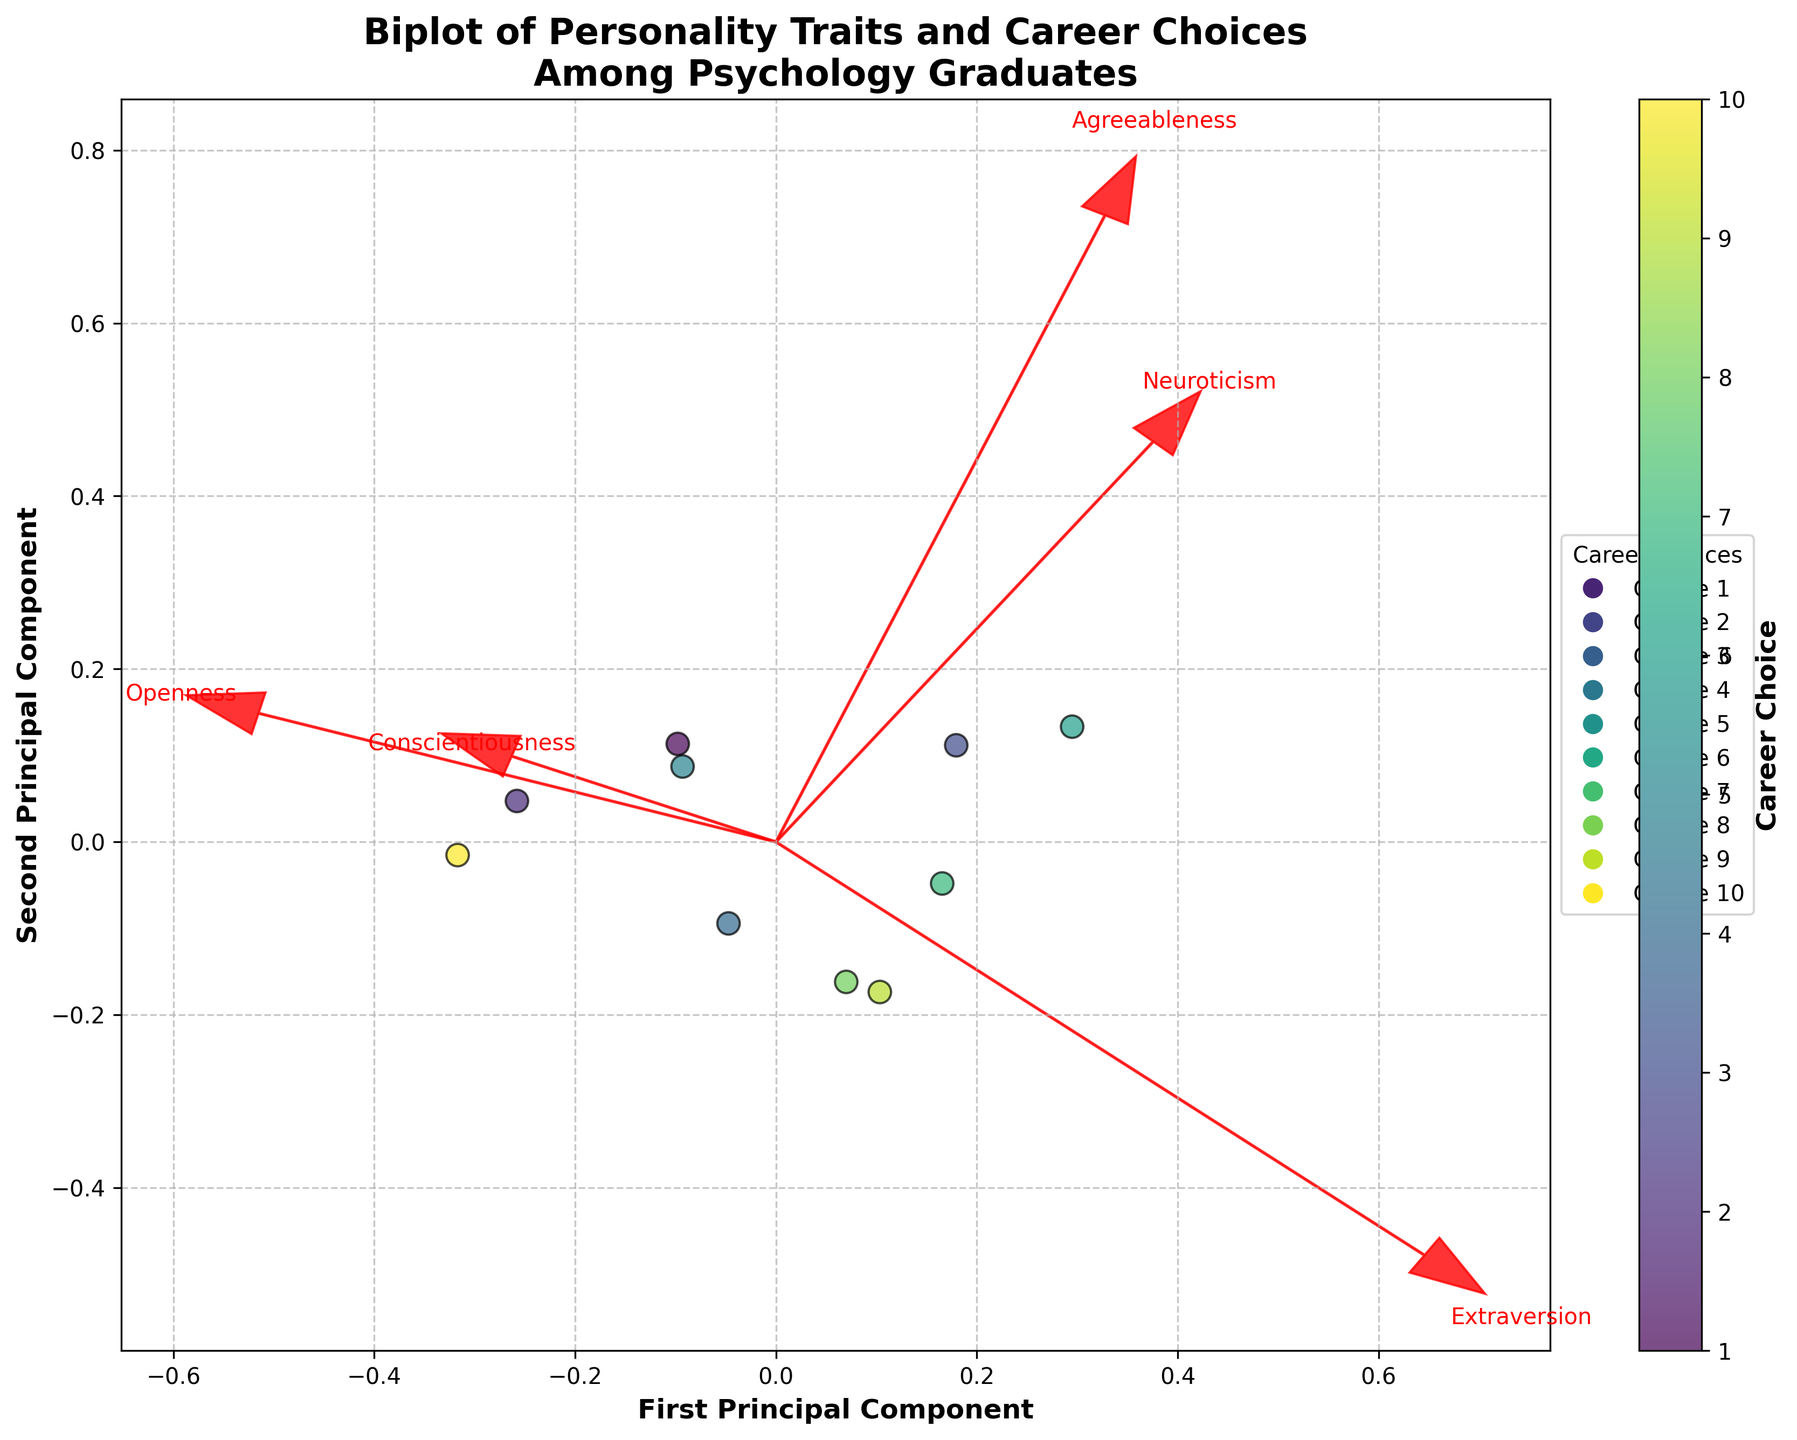what's the title of the figure? The title can be found at the top of the figure where the title text is usually placed. It reads "Biplot of Personality Traits and Career Choices\nAmong Psychology Graduates".
Answer: Biplot of Personality Traits and Career Choices Among Psychology Graduates how many career choices are represented? Count the number of unique labels from the color legend or the color bar labels. There are ten different career choices indicated by the color scale and the legend (Choice 0 to Choice 9).
Answer: 10 which personality trait has the longest arrow in the biplot? Look at the arrows representing the personality traits. The length of each arrow indicates the eigenvalue or the amount of variance explained by that trait in the principal component spaces. The arrow corresponding to "Conscientiousness" seems to be the longest.
Answer: Conscientiousness Which career is closest to the vector of "Openness"? Check the proximity of each career data point to the direction of the "Openness" vector (arrow). The "Cognitive Neuroscientist" data point appears to be the closest to the "Openness" vector.
Answer: Cognitive Neuroscientist Which two career choices are farthest apart in the biplot? Identify the pair of data points (career choices) with the greatest distance between them in the 2D plot. The "Cognitive Neuroscientist" and "Social Worker" appear to be the farthest apart.
Answer: Cognitive Neuroscientist and Social Worker Which personality trait contributes least to the first principal component? Examine the arrows representative of personality traits from the origin; for each trait, assess how much it contributes to the horizontal axis (First Principal Component). Among all, "Neuroticism" appears to have the smallest projection on this axis.
Answer: Neuroticism If you average the coordinates of the vectors of "Extraversion" and "Agreeableness", which quadrant would the point fall into? Calculate the middle point by averaging the vectors' coordinates. Both vectors seem to be predominantly in the positive x and y axes, so their average would fall in the first quadrant, where both coordinates are positive.
Answer: First Quadrant Which cluster of career choices could be thought to have high "Agreeableness" and "Extraversion"? Look for clusters close to the direction of "Agreeableness" and "Extraversion" arrows. Careers like "School Counselor", "Social Worker", and "Human Resources Specialist" are near both these directions.
Answer: School Counselor, Social Worker, Human Resources Specialist What relationship can be inferred between "Neuroticism" and career choices? Observing the direction and clustering of data points related to the "Neuroticism" arrow, it appears careers like "Social Worker" have a bit higher "Neuroticism" compared to others.
Answer: Social Worker has higher Neuroticism Which personality trait has a direction most orthogonal to "Conscientiousness"? The most orthogonal direction to an arrow is perpendicular to it. Inspect traits with vectors perpendicular to "Conscientiousness". "Neuroticism" has the most orthogonal direction to "Conscientiousness".
Answer: Neuroticism 